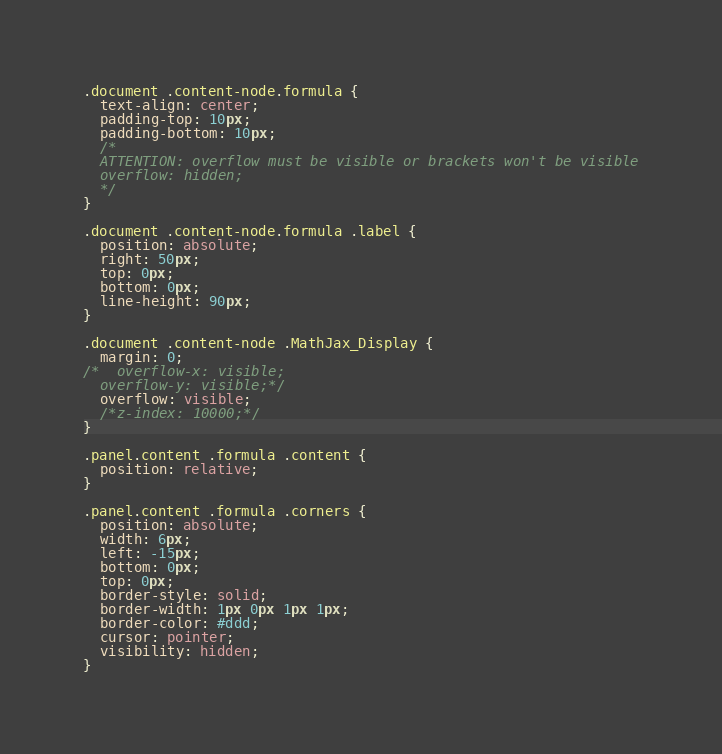<code> <loc_0><loc_0><loc_500><loc_500><_CSS_>.document .content-node.formula {
  text-align: center;
  padding-top: 10px;
  padding-bottom: 10px;
  /*
  ATTENTION: overflow must be visible or brackets won't be visible
  overflow: hidden;
  */
}

.document .content-node.formula .label {
  position: absolute;
  right: 50px;
  top: 0px;
  bottom: 0px;
  line-height: 90px;
}

.document .content-node .MathJax_Display {
  margin: 0;
/*  overflow-x: visible;
  overflow-y: visible;*/
  overflow: visible;
  /*z-index: 10000;*/
}

.panel.content .formula .content {
  position: relative;
}

.panel.content .formula .corners {
  position: absolute;
  width: 6px;
  left: -15px;
  bottom: 0px;
  top: 0px;
  border-style: solid;
  border-width: 1px 0px 1px 1px;
  border-color: #ddd;
  cursor: pointer;
  visibility: hidden;
}</code> 